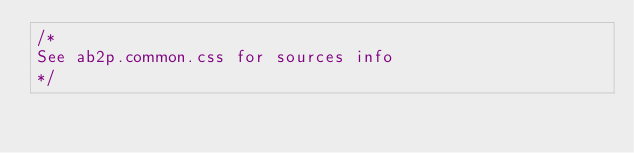Convert code to text. <code><loc_0><loc_0><loc_500><loc_500><_CSS_>/*
See ab2p.common.css for sources info
*/</code> 